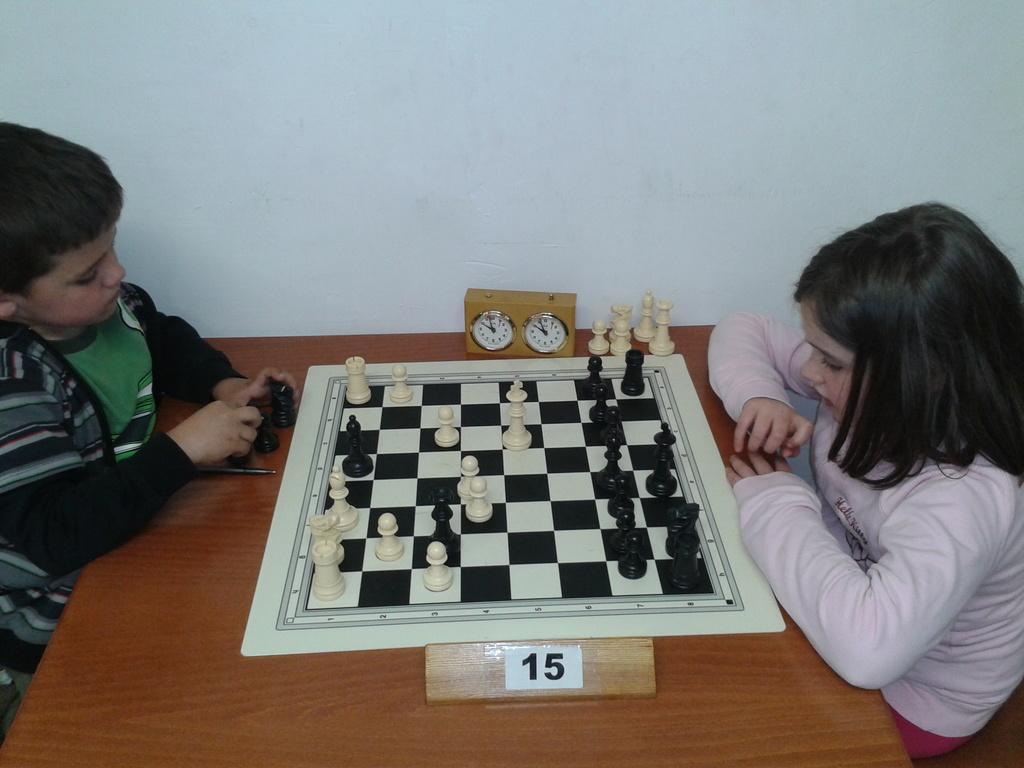Could you give a brief overview of what you see in this image? This is a picture where we have 2 persons sitting in the chair and playing chess board with a timer in the table. 